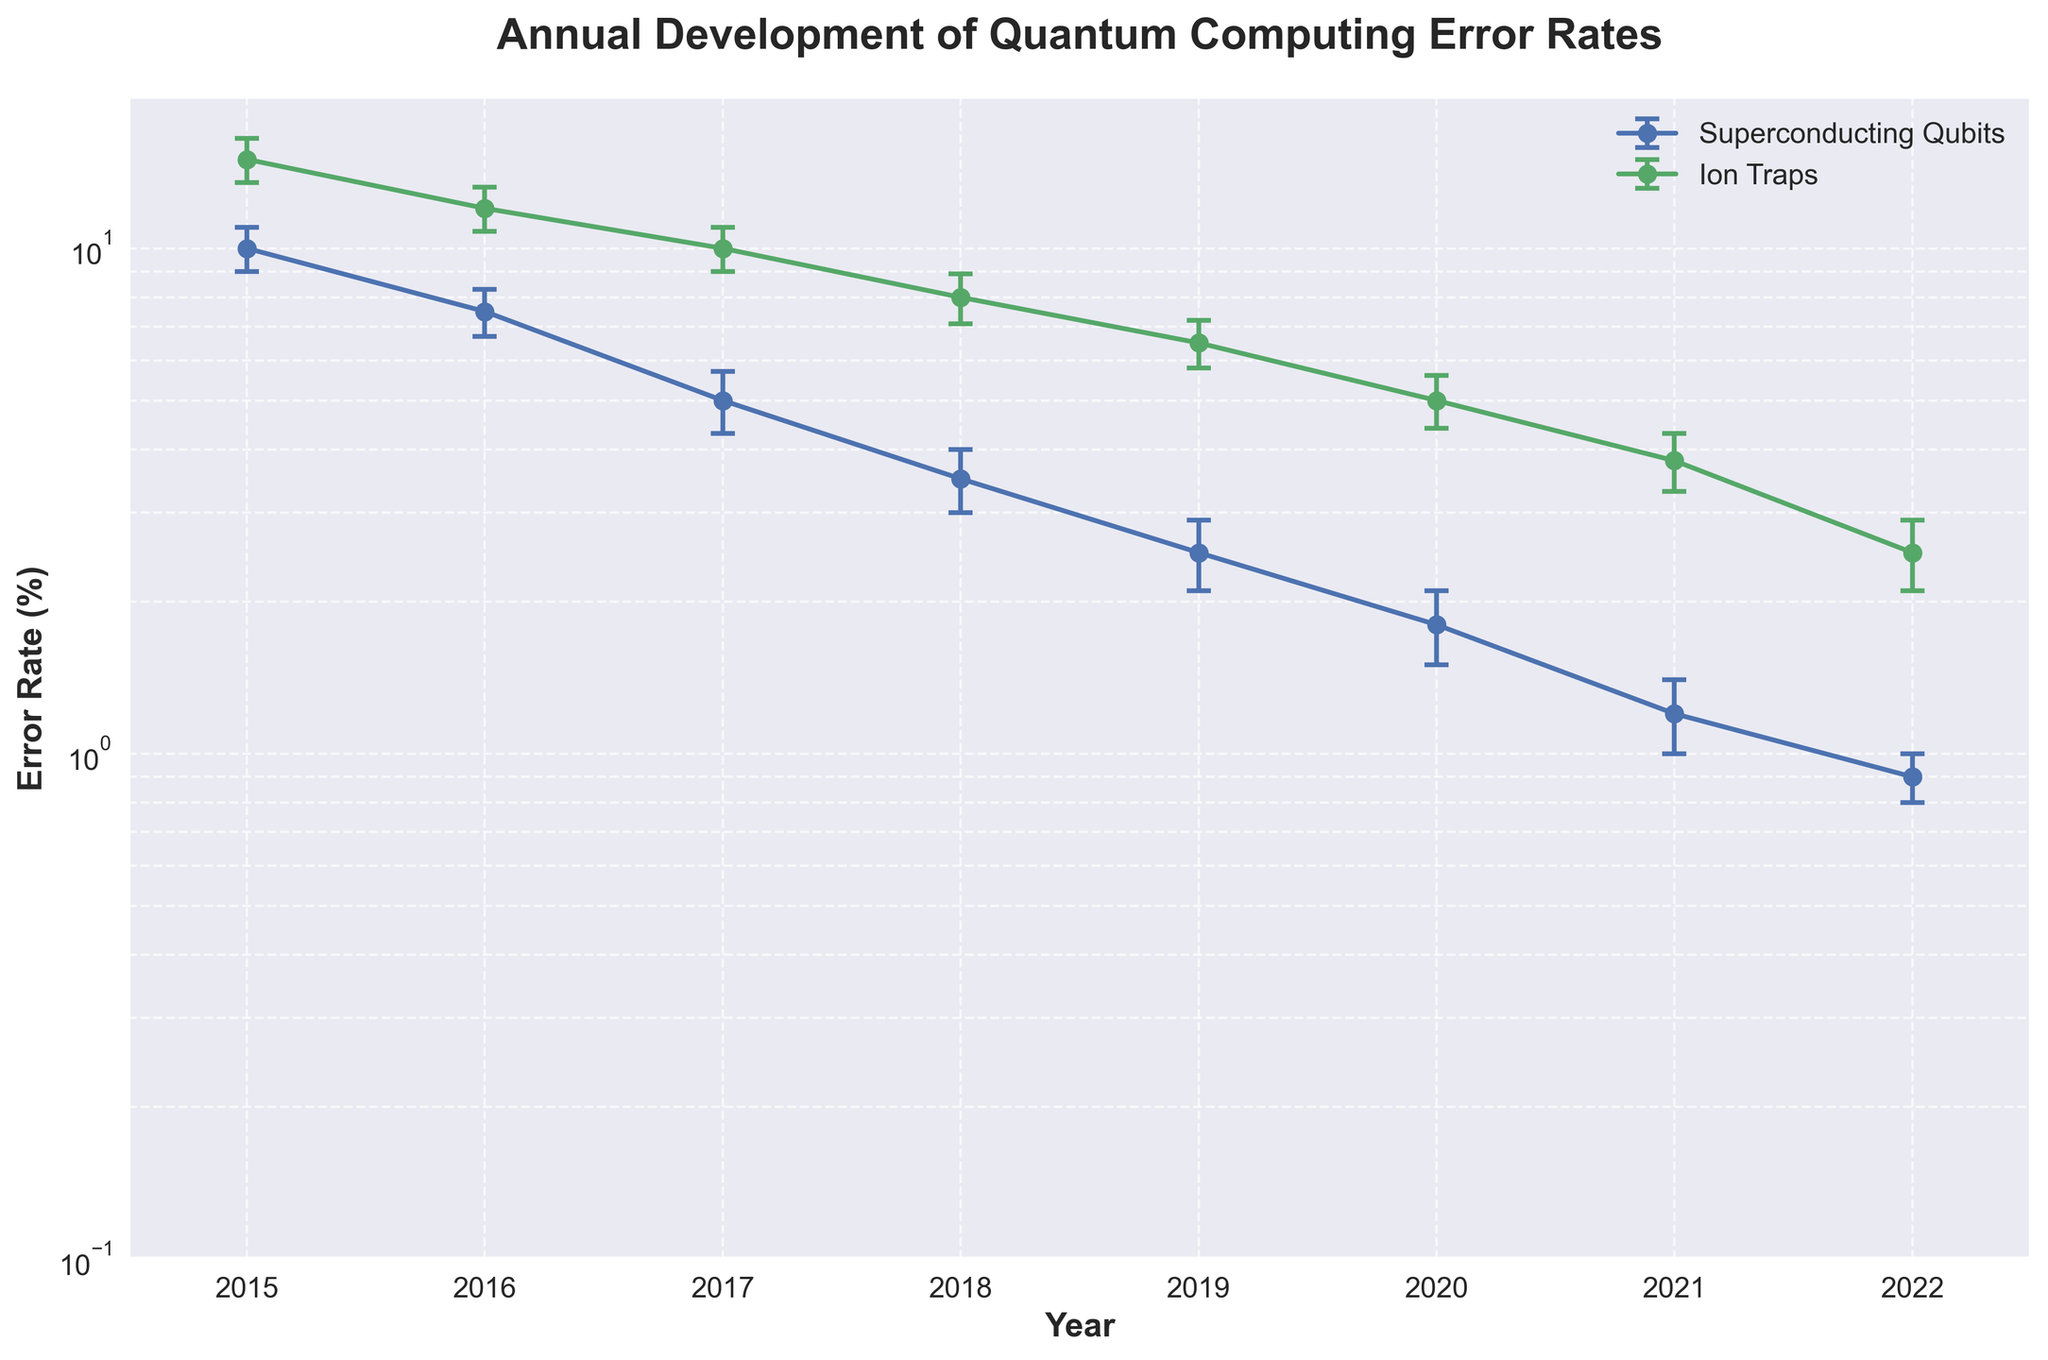What is the title of the figure? The title is located at the top center of the figure, written in bold. The large text clearly indicates the main purpose of the plot, summarizing the data being presented.
Answer: Annual Development of Quantum Computing Error Rates Which year's data shows the highest error rate for Ion Traps? To find this, examine the plot and identify the highest point in the vertical axis for the Ion Traps line. This peak corresponds to the year where Ion Traps had the highest error rate.
Answer: 2015 What is the general trend of error rates for Superconducting Qubits from 2015 to 2022? Follow the line representing Superconducting Qubits from 2015 to 2022 in the horizontal axis. Notice that the error rates decrease consistently over the years.
Answer: Decreasing In what year do Superconducting Qubits and Ion Traps first have error rates below 10%? Check both lines for the first point along the horizontal axis where the vertical axis value drops below 10%. For Superconducting Qubits, it happens in 2017, and for Ion Traps, it happens in 2018.
Answer: 2017 for Superconducting Qubits, 2018 for Ion Traps How do the error rate uncertainties for Ion Traps compare between 2015 and 2022? Examine the error bars (lines indicating uncertainties) for Ion Traps in 2015 and 2022. The length of the error bars shows the magnitude of uncertainty.
Answer: The uncertainty is larger in 2015 (±1.5%) compared to 2022 (±0.4%) In which year did both hardware approaches have their closest error rates? Look for the points where the lines representing both hardware approaches are closest to each other vertically. Measure the error rate differences visually for each year to find the one with the smallest difference.
Answer: 2020 What is the difference between the error rates of Ion Traps and Superconducting Qubits in 2016? Locate the error rate values for both Ion Traps (12%) and Superconducting Qubits (7.5%) in 2016, then subtract the smaller rate from the larger rate.
Answer: 4.5% What pattern do you observe in the error bars for Superconducting Qubits over the years? Identify if the error bars (representing uncertainty) for Superconducting Qubits get smaller, larger, or remain consistent from 2015 to 2022.
Answer: Decreasing At what year did Ion Traps have an error rate below 5% for the first time? Find the point along the Ion Traps line where the error rate first dips below the 5% mark on the vertical axis, which occurs in 2021.
Answer: 2021 Which hardware approach had a more consistent decrease in error rates over the years? Observe the overall slope and smoothness of the downward trend in both lines. The line with the more consistent downward trajectory indicates the more consistent decrease.
Answer: Superconducting Qubits 